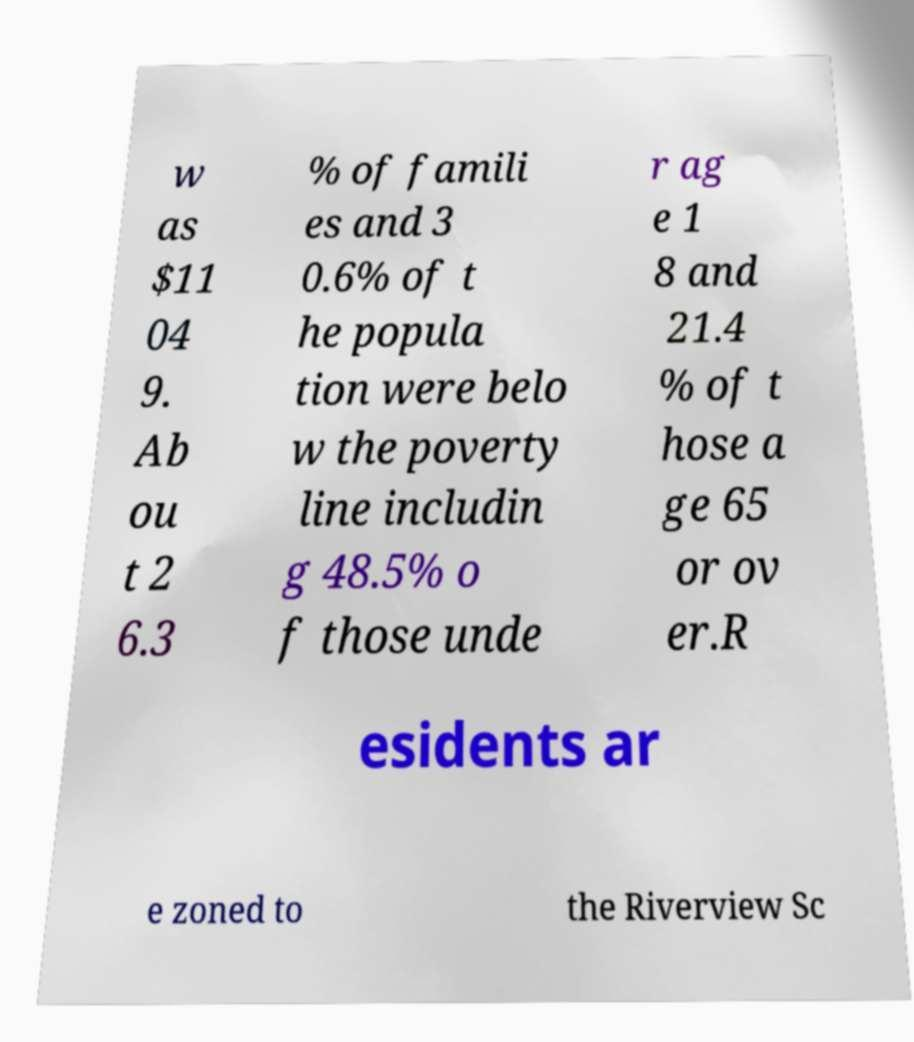Could you extract and type out the text from this image? w as $11 04 9. Ab ou t 2 6.3 % of famili es and 3 0.6% of t he popula tion were belo w the poverty line includin g 48.5% o f those unde r ag e 1 8 and 21.4 % of t hose a ge 65 or ov er.R esidents ar e zoned to the Riverview Sc 